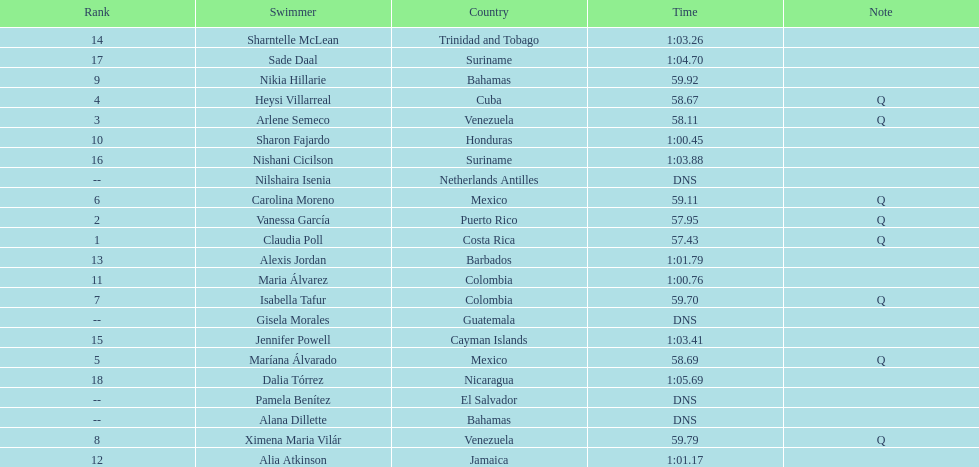Who was the last competitor to actually finish the preliminaries? Dalia Tórrez. 